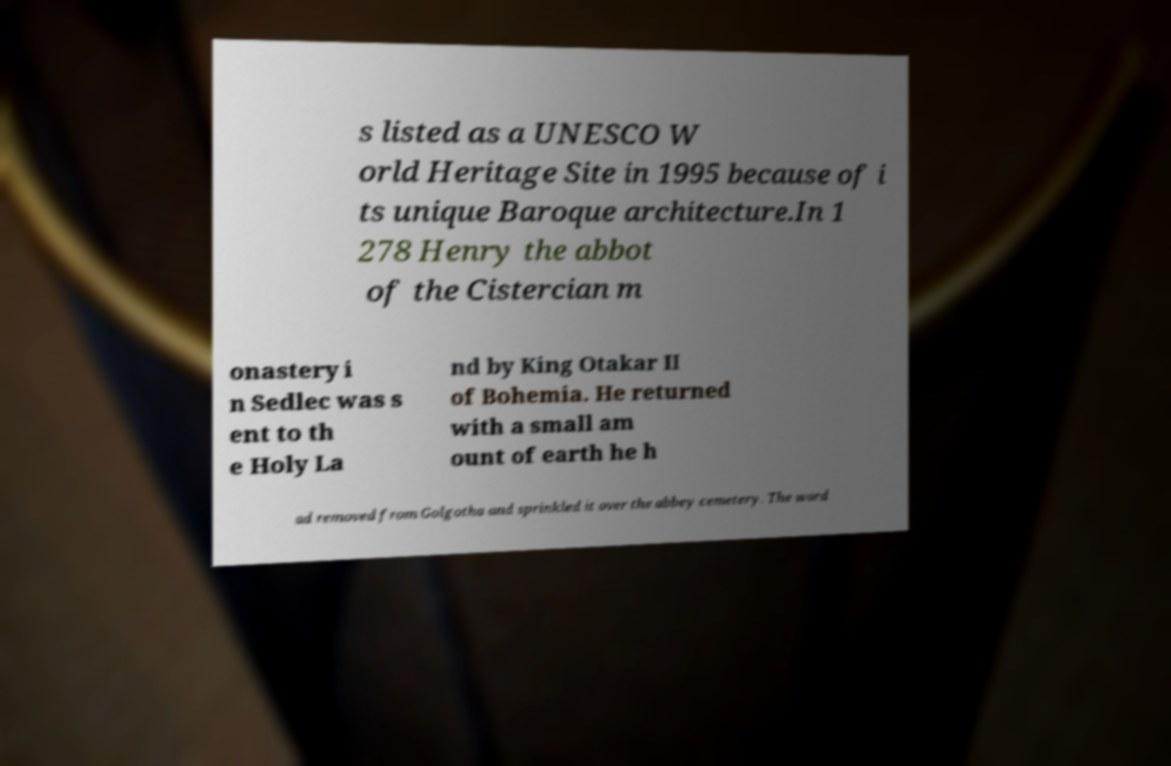Please identify and transcribe the text found in this image. s listed as a UNESCO W orld Heritage Site in 1995 because of i ts unique Baroque architecture.In 1 278 Henry the abbot of the Cistercian m onastery i n Sedlec was s ent to th e Holy La nd by King Otakar II of Bohemia. He returned with a small am ount of earth he h ad removed from Golgotha and sprinkled it over the abbey cemetery. The word 